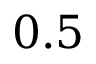Convert formula to latex. <formula><loc_0><loc_0><loc_500><loc_500>0 . 5</formula> 